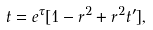<formula> <loc_0><loc_0><loc_500><loc_500>t = e ^ { \tau } [ 1 - r ^ { 2 } + r ^ { 2 } t ^ { \prime } ] ,</formula> 